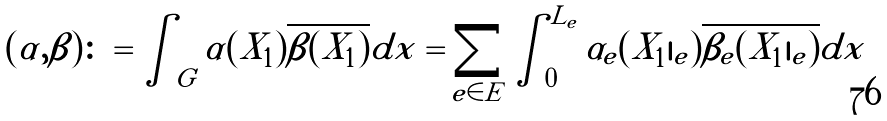<formula> <loc_0><loc_0><loc_500><loc_500>( \alpha , \beta ) \colon = \int _ { G } \alpha ( X _ { 1 } ) \overline { \beta ( X _ { 1 } ) } d x = \sum _ { e \in E } \int _ { 0 } ^ { L _ { e } } \alpha _ { e } ( X _ { 1 } | _ { e } ) \overline { \beta _ { e } ( X _ { 1 } | _ { e } ) } d x</formula> 